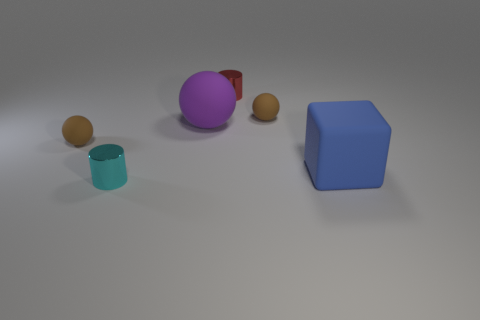There is a brown object right of the red cylinder; what is its shape?
Provide a succinct answer. Sphere. Does the rubber block that is behind the tiny cyan shiny cylinder have the same color as the tiny rubber sphere that is on the left side of the cyan object?
Keep it short and to the point. No. Is there a large purple matte sphere?
Keep it short and to the point. Yes. There is a tiny brown thing that is left of the small rubber ball right of the rubber sphere that is to the left of the tiny cyan metallic object; what is its shape?
Your response must be concise. Sphere. What number of cylinders are behind the block?
Your response must be concise. 1. Do the sphere that is to the left of the tiny cyan shiny object and the small red cylinder have the same material?
Ensure brevity in your answer.  No. How many other things are there of the same shape as the large blue matte object?
Your answer should be compact. 0. There is a tiny metal cylinder that is to the left of the cylinder that is right of the cyan cylinder; how many rubber spheres are left of it?
Ensure brevity in your answer.  1. What is the color of the metal cylinder in front of the big rubber sphere?
Provide a succinct answer. Cyan. There is a small metal cylinder right of the large purple object; is its color the same as the large matte ball?
Your response must be concise. No. 